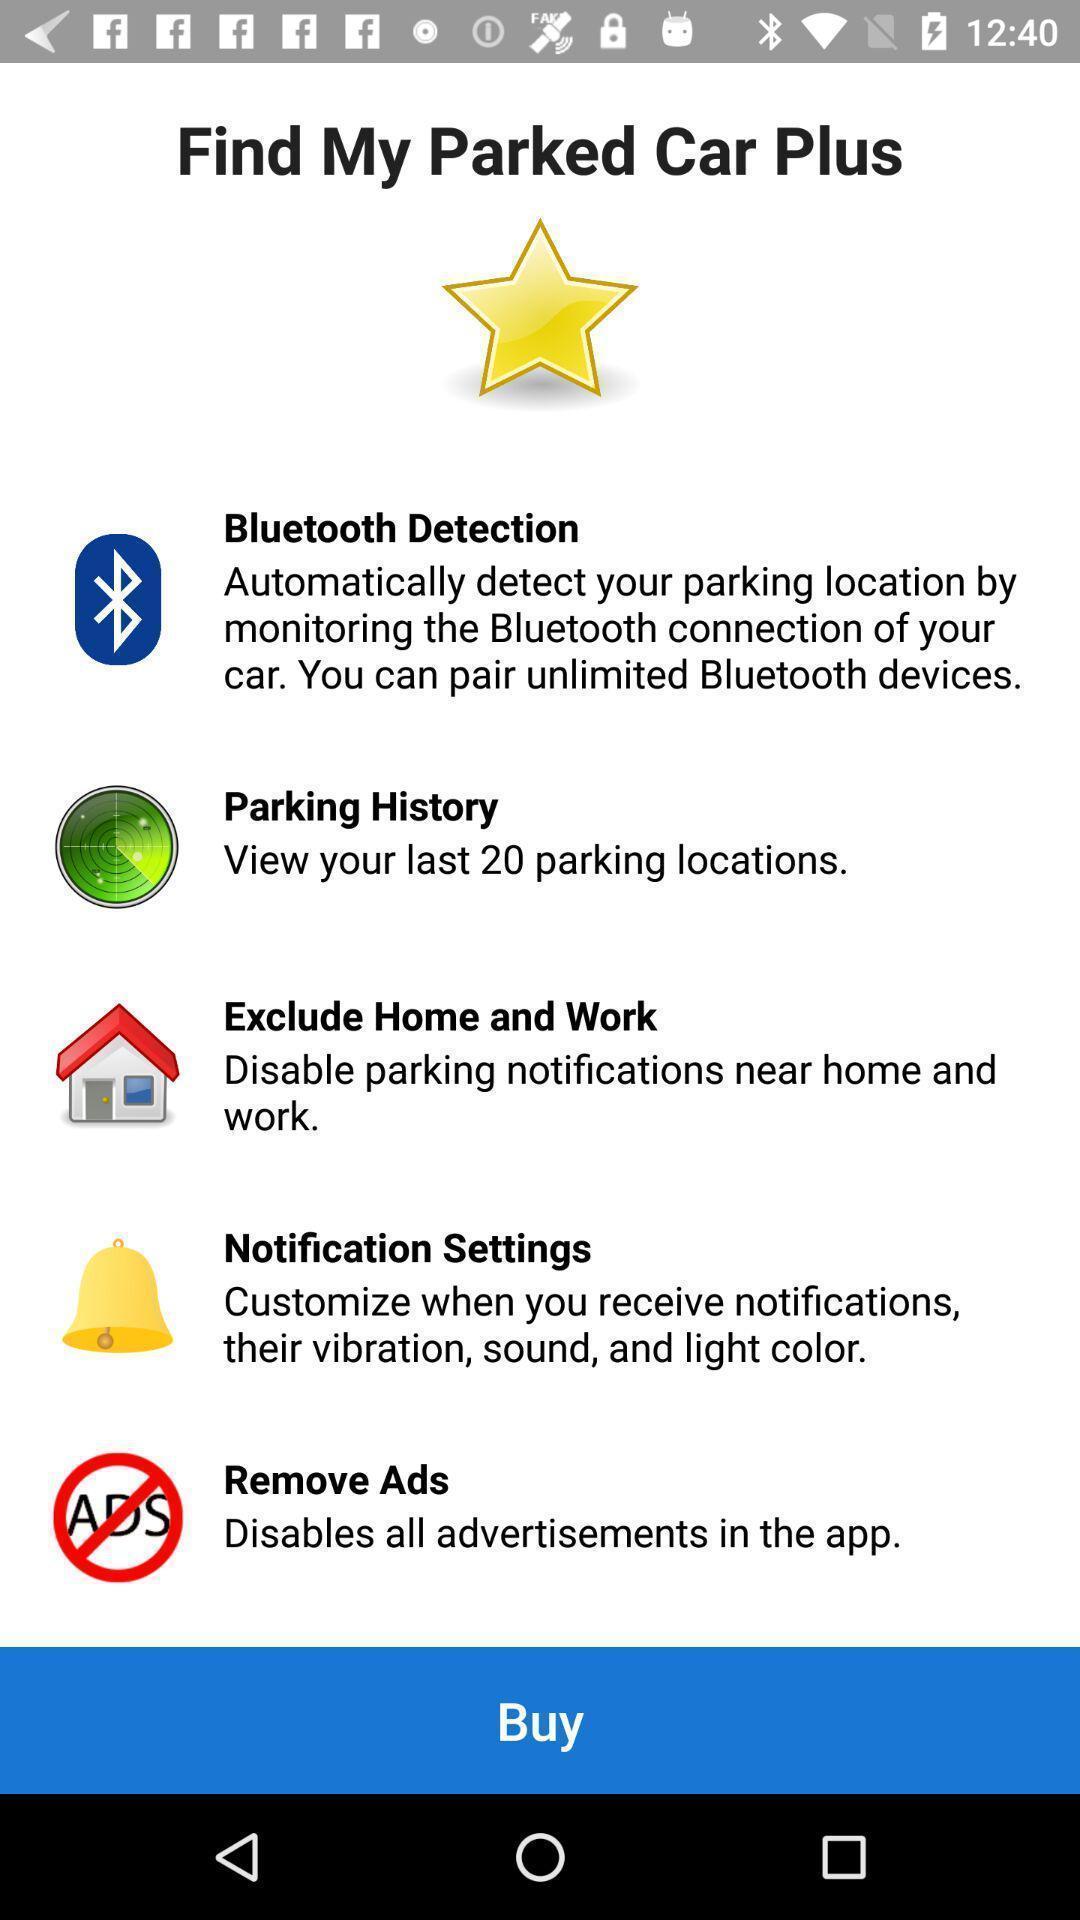Give me a summary of this screen capture. Various options in a car parking detection app. 